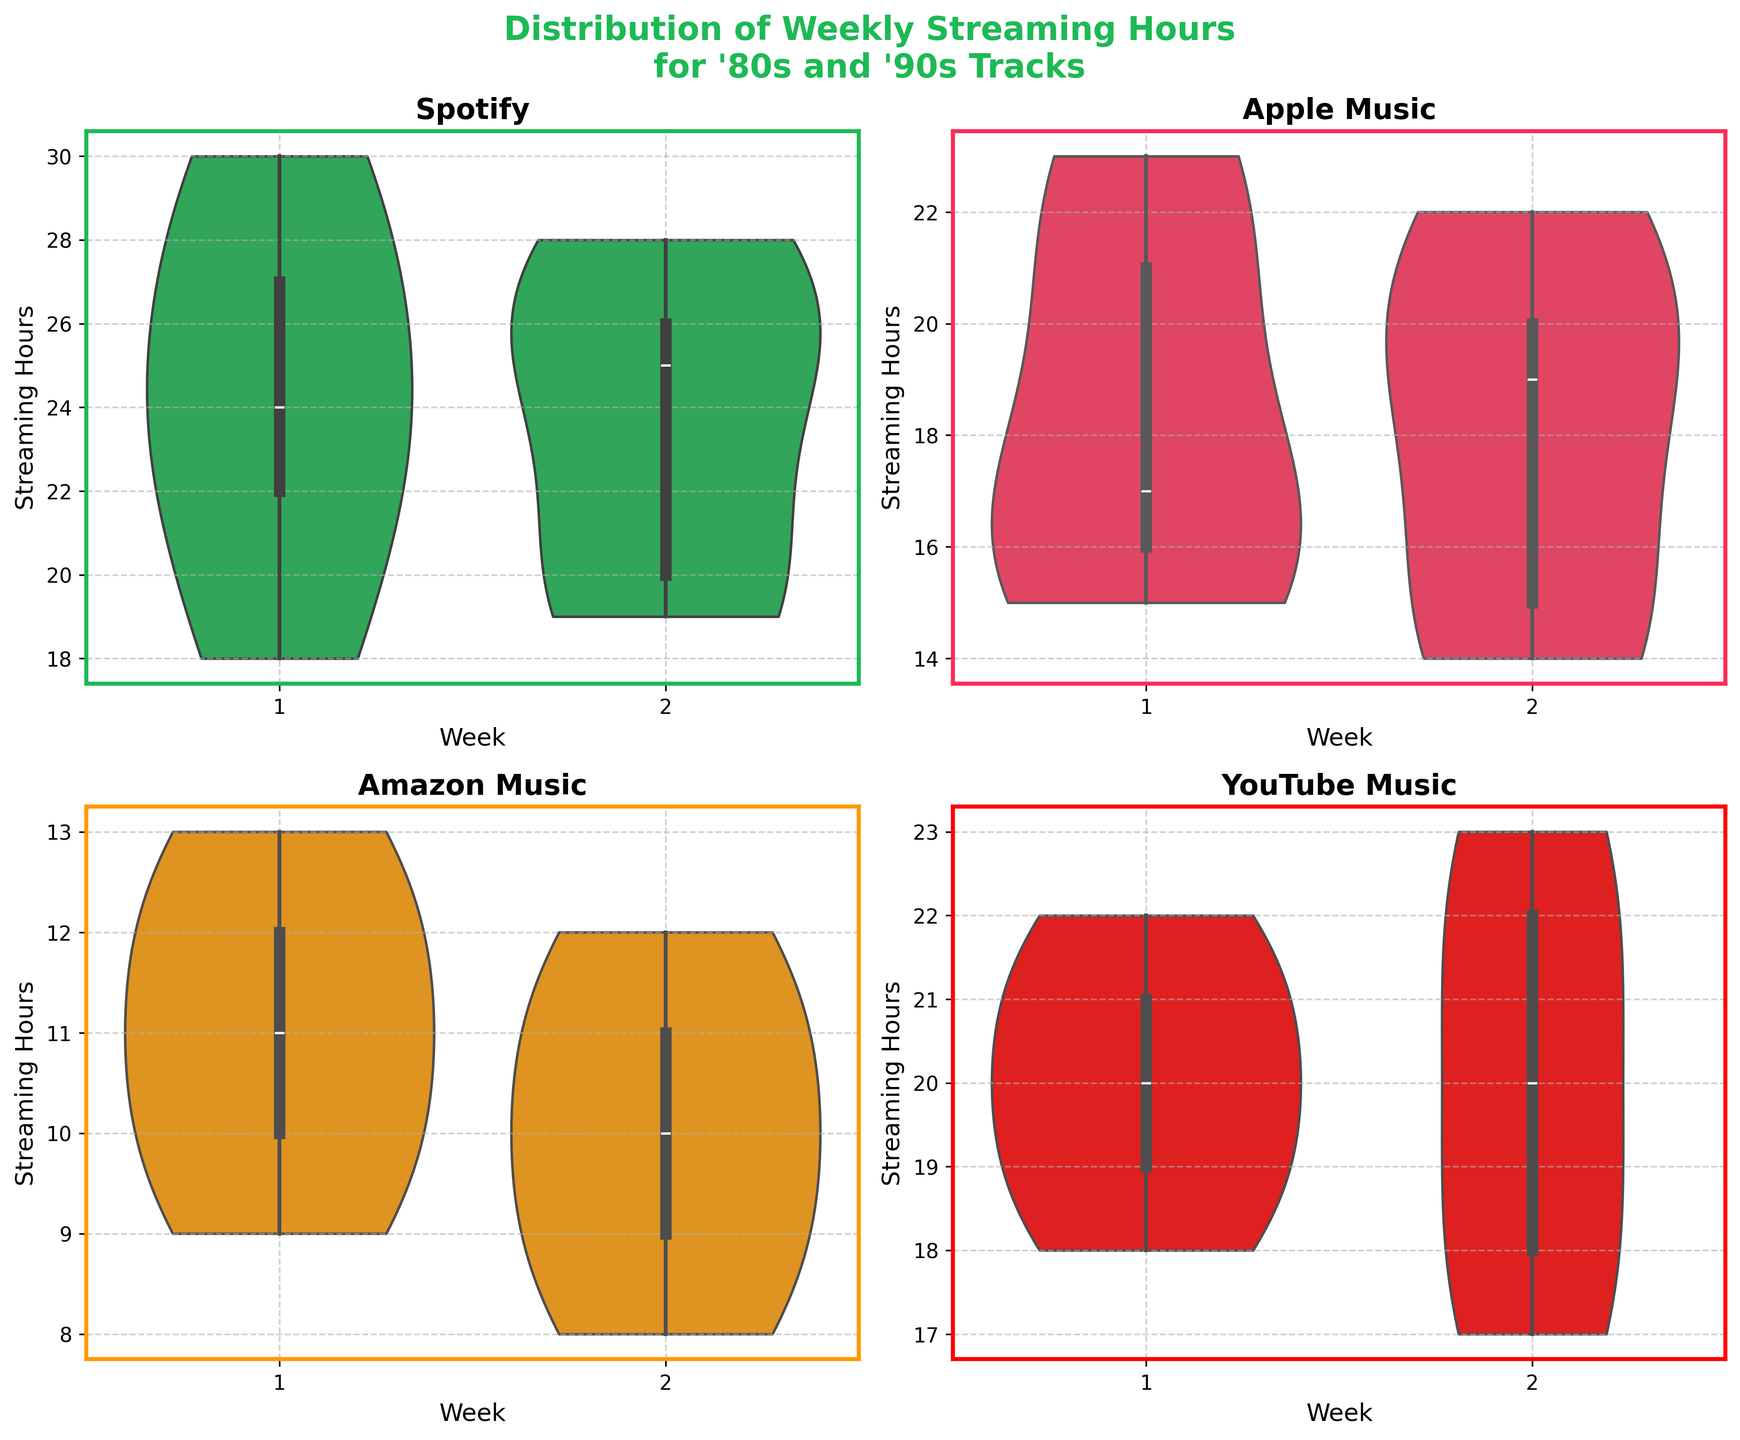Which platform has the highest range of streaming hours in Week 1? Observing the ends of the violins for Week 1 for each platform: Spotify's violin spans from 18 to 30 hours, Apple Music from 15 to 23 hours, Amazon Music from 9 to 13 hours, and YouTube Music from 18 to 22 hours. Spotify has the highest range.
Answer: Spotify Which platform shows the most symmetric distribution of streaming hours in Week 2? In Week 2, the symmetry of the distributions can be checked from how evenly the violins expand on both sides of the box. YouTube Music has a more symmetric appearance compared to others, as it does not show more spread on one side.
Answer: YouTube Music Is the median streaming hours higher for Spotify or Apple Music in Week 1? The median is indicated by the line within the violin plot's 'box'. By comparing the position of the lines, the median for Spotify appears higher than for Apple Music in Week 1.
Answer: Spotify Which platform has a more consistent streaming hours between Week 1 and Week 2? Consistency can be determined by the overlap and spread of the violins through both weeks. Both weeks of Apple Music and Amazon Music show very similar shapes and spreads, but Amazon Music shows a very consistent pattern.
Answer: Amazon Music Do any platforms show a noticeable difference in the distribution between Week 1 and Week 2? By comparing the shapes of the violins between weeks, Spotify in Week 2 shows a slightly narrower range and different distribution spread compared to Week 1, indicating a noticeable difference.
Answer: Spotify Which platform has the lowest median streaming hours in Week 2? The median value is indicated by the horizontal line within the violin 'box'. Comparing them, Amazon Music has the lowest median in Week 2.
Answer: Amazon Music 